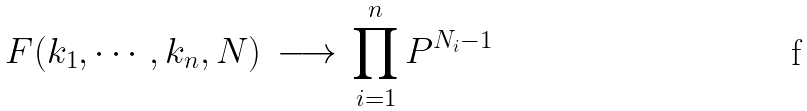<formula> <loc_0><loc_0><loc_500><loc_500>F ( k _ { 1 } , \cdots , k _ { n } , N ) \, \longrightarrow \, \prod _ { i = 1 } ^ { n } { P } ^ { N _ { i } - 1 }</formula> 